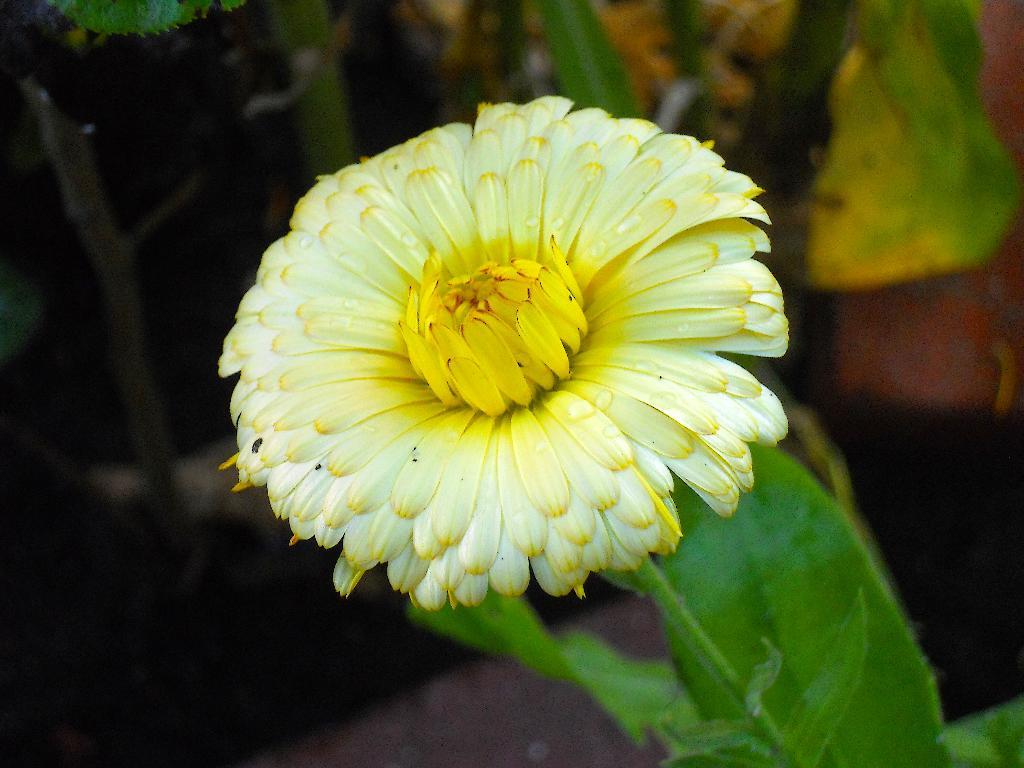What type of plant is visible in the image? There is a flower and a leaf in the image. Can you describe the appearance of the flower? Unfortunately, the specific appearance of the flower cannot be determined from the provided facts. What other plant part is visible in the image? There is a leaf in the image. How many cats are sitting on the bait in the image? There are no cats or bait present in the image; it only features a flower and a leaf. 